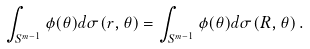<formula> <loc_0><loc_0><loc_500><loc_500>\int _ { S ^ { m - 1 } } \phi ( \theta ) d \sigma ( r , \theta ) = \int _ { S ^ { m - 1 } } \phi ( \theta ) d \sigma ( R , \theta ) \, .</formula> 